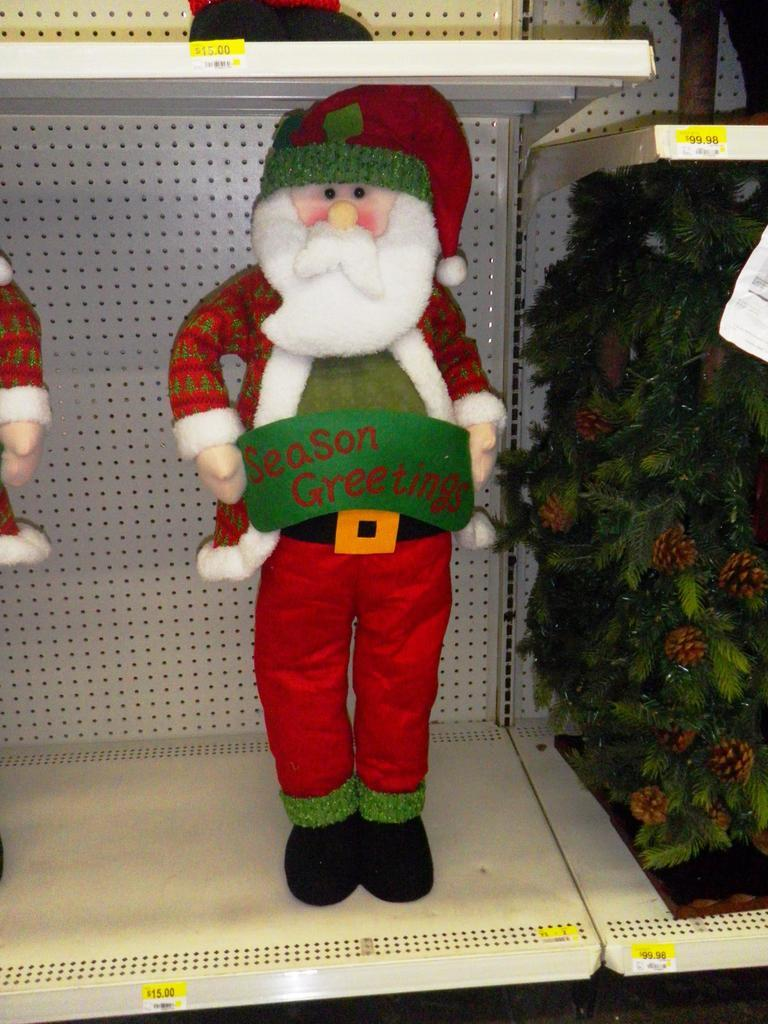Provide a one-sentence caption for the provided image. a santa claus in a store holding a banner that says 'season greetings'. 